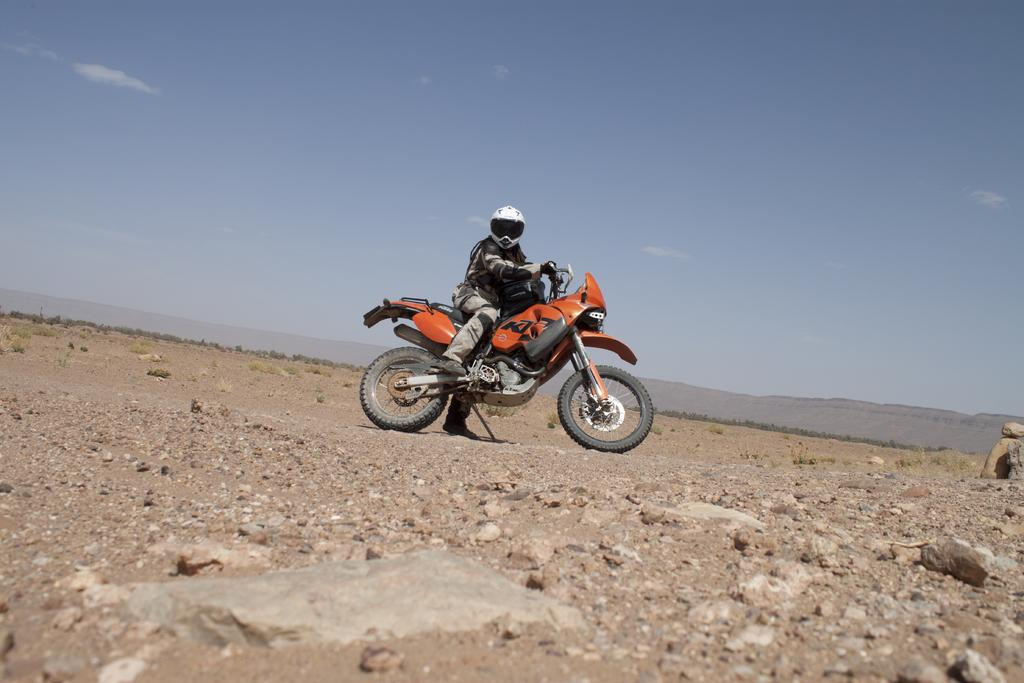What is on the ground in the image? There are stones on the ground in the image. What is the man in the image doing? The man is sitting on a bike in the image. What color is the bike? The bike is orange in color. What is the condition of the sky in the image? The sky is cloudy in the image. What type of curtain can be seen hanging from the bike in the image? There is no curtain present in the image; it features a man sitting on an orange bike with stones on the ground and a cloudy sky. How many trains are visible in the image? There are no trains visible in the image; it features a man sitting on an orange bike with stones on the ground and a cloudy sky. 